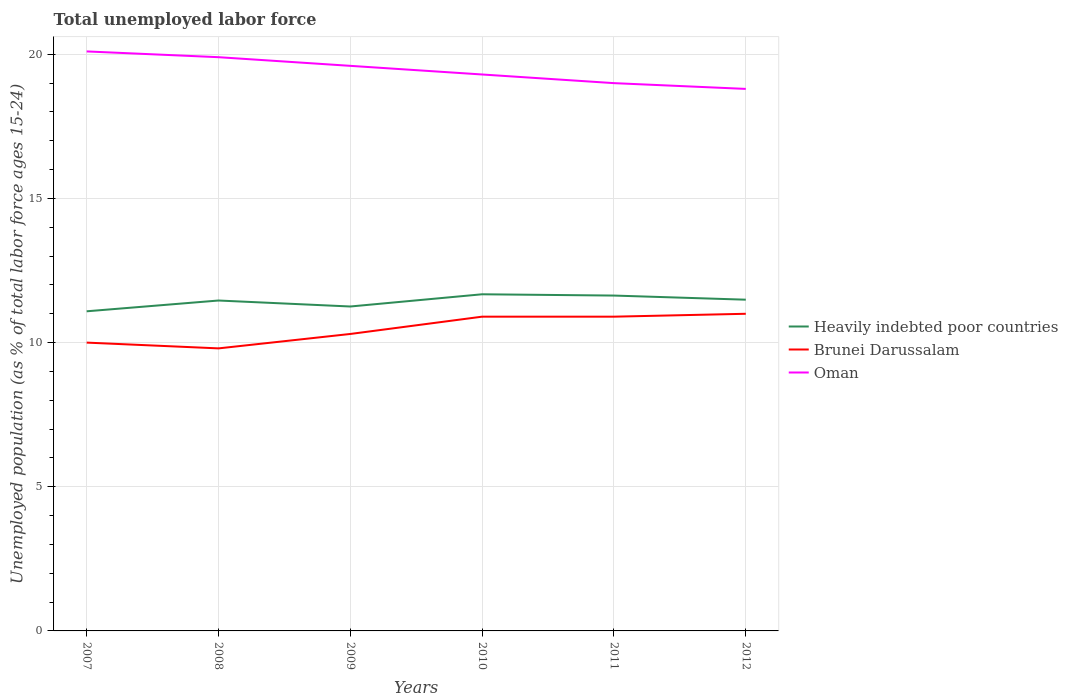Across all years, what is the maximum percentage of unemployed population in in Heavily indebted poor countries?
Give a very brief answer. 11.09. What is the total percentage of unemployed population in in Oman in the graph?
Keep it short and to the point. 1.1. What is the difference between the highest and the second highest percentage of unemployed population in in Oman?
Keep it short and to the point. 1.3. Is the percentage of unemployed population in in Brunei Darussalam strictly greater than the percentage of unemployed population in in Heavily indebted poor countries over the years?
Your response must be concise. Yes. How many lines are there?
Provide a short and direct response. 3. How many years are there in the graph?
Provide a succinct answer. 6. Does the graph contain any zero values?
Offer a very short reply. No. Where does the legend appear in the graph?
Offer a very short reply. Center right. How many legend labels are there?
Your response must be concise. 3. How are the legend labels stacked?
Make the answer very short. Vertical. What is the title of the graph?
Your answer should be compact. Total unemployed labor force. What is the label or title of the Y-axis?
Your answer should be very brief. Unemployed population (as % of total labor force ages 15-24). What is the Unemployed population (as % of total labor force ages 15-24) of Heavily indebted poor countries in 2007?
Offer a very short reply. 11.09. What is the Unemployed population (as % of total labor force ages 15-24) in Brunei Darussalam in 2007?
Ensure brevity in your answer.  10. What is the Unemployed population (as % of total labor force ages 15-24) of Oman in 2007?
Give a very brief answer. 20.1. What is the Unemployed population (as % of total labor force ages 15-24) in Heavily indebted poor countries in 2008?
Your response must be concise. 11.46. What is the Unemployed population (as % of total labor force ages 15-24) of Brunei Darussalam in 2008?
Provide a short and direct response. 9.8. What is the Unemployed population (as % of total labor force ages 15-24) in Oman in 2008?
Offer a very short reply. 19.9. What is the Unemployed population (as % of total labor force ages 15-24) in Heavily indebted poor countries in 2009?
Provide a succinct answer. 11.25. What is the Unemployed population (as % of total labor force ages 15-24) of Brunei Darussalam in 2009?
Your response must be concise. 10.3. What is the Unemployed population (as % of total labor force ages 15-24) of Oman in 2009?
Give a very brief answer. 19.6. What is the Unemployed population (as % of total labor force ages 15-24) of Heavily indebted poor countries in 2010?
Make the answer very short. 11.68. What is the Unemployed population (as % of total labor force ages 15-24) of Brunei Darussalam in 2010?
Give a very brief answer. 10.9. What is the Unemployed population (as % of total labor force ages 15-24) of Oman in 2010?
Offer a terse response. 19.3. What is the Unemployed population (as % of total labor force ages 15-24) of Heavily indebted poor countries in 2011?
Offer a terse response. 11.63. What is the Unemployed population (as % of total labor force ages 15-24) in Brunei Darussalam in 2011?
Your answer should be compact. 10.9. What is the Unemployed population (as % of total labor force ages 15-24) in Oman in 2011?
Provide a succinct answer. 19. What is the Unemployed population (as % of total labor force ages 15-24) in Heavily indebted poor countries in 2012?
Give a very brief answer. 11.49. What is the Unemployed population (as % of total labor force ages 15-24) in Brunei Darussalam in 2012?
Provide a succinct answer. 11. What is the Unemployed population (as % of total labor force ages 15-24) of Oman in 2012?
Provide a succinct answer. 18.8. Across all years, what is the maximum Unemployed population (as % of total labor force ages 15-24) of Heavily indebted poor countries?
Make the answer very short. 11.68. Across all years, what is the maximum Unemployed population (as % of total labor force ages 15-24) of Oman?
Provide a succinct answer. 20.1. Across all years, what is the minimum Unemployed population (as % of total labor force ages 15-24) of Heavily indebted poor countries?
Your answer should be very brief. 11.09. Across all years, what is the minimum Unemployed population (as % of total labor force ages 15-24) of Brunei Darussalam?
Ensure brevity in your answer.  9.8. Across all years, what is the minimum Unemployed population (as % of total labor force ages 15-24) of Oman?
Make the answer very short. 18.8. What is the total Unemployed population (as % of total labor force ages 15-24) of Heavily indebted poor countries in the graph?
Provide a short and direct response. 68.6. What is the total Unemployed population (as % of total labor force ages 15-24) in Brunei Darussalam in the graph?
Offer a terse response. 62.9. What is the total Unemployed population (as % of total labor force ages 15-24) in Oman in the graph?
Make the answer very short. 116.7. What is the difference between the Unemployed population (as % of total labor force ages 15-24) of Heavily indebted poor countries in 2007 and that in 2008?
Ensure brevity in your answer.  -0.37. What is the difference between the Unemployed population (as % of total labor force ages 15-24) of Brunei Darussalam in 2007 and that in 2008?
Your answer should be very brief. 0.2. What is the difference between the Unemployed population (as % of total labor force ages 15-24) in Heavily indebted poor countries in 2007 and that in 2009?
Provide a succinct answer. -0.17. What is the difference between the Unemployed population (as % of total labor force ages 15-24) in Brunei Darussalam in 2007 and that in 2009?
Your answer should be very brief. -0.3. What is the difference between the Unemployed population (as % of total labor force ages 15-24) in Oman in 2007 and that in 2009?
Give a very brief answer. 0.5. What is the difference between the Unemployed population (as % of total labor force ages 15-24) of Heavily indebted poor countries in 2007 and that in 2010?
Give a very brief answer. -0.59. What is the difference between the Unemployed population (as % of total labor force ages 15-24) of Heavily indebted poor countries in 2007 and that in 2011?
Keep it short and to the point. -0.55. What is the difference between the Unemployed population (as % of total labor force ages 15-24) of Oman in 2007 and that in 2011?
Offer a very short reply. 1.1. What is the difference between the Unemployed population (as % of total labor force ages 15-24) of Heavily indebted poor countries in 2007 and that in 2012?
Make the answer very short. -0.4. What is the difference between the Unemployed population (as % of total labor force ages 15-24) of Brunei Darussalam in 2007 and that in 2012?
Ensure brevity in your answer.  -1. What is the difference between the Unemployed population (as % of total labor force ages 15-24) in Oman in 2007 and that in 2012?
Your answer should be very brief. 1.3. What is the difference between the Unemployed population (as % of total labor force ages 15-24) in Heavily indebted poor countries in 2008 and that in 2009?
Your answer should be very brief. 0.21. What is the difference between the Unemployed population (as % of total labor force ages 15-24) of Brunei Darussalam in 2008 and that in 2009?
Your answer should be compact. -0.5. What is the difference between the Unemployed population (as % of total labor force ages 15-24) of Oman in 2008 and that in 2009?
Your answer should be very brief. 0.3. What is the difference between the Unemployed population (as % of total labor force ages 15-24) of Heavily indebted poor countries in 2008 and that in 2010?
Offer a terse response. -0.22. What is the difference between the Unemployed population (as % of total labor force ages 15-24) in Oman in 2008 and that in 2010?
Make the answer very short. 0.6. What is the difference between the Unemployed population (as % of total labor force ages 15-24) in Heavily indebted poor countries in 2008 and that in 2011?
Your response must be concise. -0.17. What is the difference between the Unemployed population (as % of total labor force ages 15-24) in Brunei Darussalam in 2008 and that in 2011?
Ensure brevity in your answer.  -1.1. What is the difference between the Unemployed population (as % of total labor force ages 15-24) of Heavily indebted poor countries in 2008 and that in 2012?
Your response must be concise. -0.03. What is the difference between the Unemployed population (as % of total labor force ages 15-24) in Oman in 2008 and that in 2012?
Offer a terse response. 1.1. What is the difference between the Unemployed population (as % of total labor force ages 15-24) in Heavily indebted poor countries in 2009 and that in 2010?
Provide a short and direct response. -0.42. What is the difference between the Unemployed population (as % of total labor force ages 15-24) in Brunei Darussalam in 2009 and that in 2010?
Your response must be concise. -0.6. What is the difference between the Unemployed population (as % of total labor force ages 15-24) of Oman in 2009 and that in 2010?
Offer a very short reply. 0.3. What is the difference between the Unemployed population (as % of total labor force ages 15-24) in Heavily indebted poor countries in 2009 and that in 2011?
Make the answer very short. -0.38. What is the difference between the Unemployed population (as % of total labor force ages 15-24) in Heavily indebted poor countries in 2009 and that in 2012?
Ensure brevity in your answer.  -0.24. What is the difference between the Unemployed population (as % of total labor force ages 15-24) of Brunei Darussalam in 2009 and that in 2012?
Give a very brief answer. -0.7. What is the difference between the Unemployed population (as % of total labor force ages 15-24) in Heavily indebted poor countries in 2010 and that in 2011?
Ensure brevity in your answer.  0.04. What is the difference between the Unemployed population (as % of total labor force ages 15-24) in Heavily indebted poor countries in 2010 and that in 2012?
Your response must be concise. 0.19. What is the difference between the Unemployed population (as % of total labor force ages 15-24) in Heavily indebted poor countries in 2011 and that in 2012?
Provide a short and direct response. 0.14. What is the difference between the Unemployed population (as % of total labor force ages 15-24) in Brunei Darussalam in 2011 and that in 2012?
Provide a short and direct response. -0.1. What is the difference between the Unemployed population (as % of total labor force ages 15-24) of Oman in 2011 and that in 2012?
Make the answer very short. 0.2. What is the difference between the Unemployed population (as % of total labor force ages 15-24) in Heavily indebted poor countries in 2007 and the Unemployed population (as % of total labor force ages 15-24) in Brunei Darussalam in 2008?
Your response must be concise. 1.29. What is the difference between the Unemployed population (as % of total labor force ages 15-24) in Heavily indebted poor countries in 2007 and the Unemployed population (as % of total labor force ages 15-24) in Oman in 2008?
Keep it short and to the point. -8.81. What is the difference between the Unemployed population (as % of total labor force ages 15-24) in Heavily indebted poor countries in 2007 and the Unemployed population (as % of total labor force ages 15-24) in Brunei Darussalam in 2009?
Provide a short and direct response. 0.79. What is the difference between the Unemployed population (as % of total labor force ages 15-24) of Heavily indebted poor countries in 2007 and the Unemployed population (as % of total labor force ages 15-24) of Oman in 2009?
Offer a terse response. -8.51. What is the difference between the Unemployed population (as % of total labor force ages 15-24) in Brunei Darussalam in 2007 and the Unemployed population (as % of total labor force ages 15-24) in Oman in 2009?
Keep it short and to the point. -9.6. What is the difference between the Unemployed population (as % of total labor force ages 15-24) in Heavily indebted poor countries in 2007 and the Unemployed population (as % of total labor force ages 15-24) in Brunei Darussalam in 2010?
Your response must be concise. 0.19. What is the difference between the Unemployed population (as % of total labor force ages 15-24) of Heavily indebted poor countries in 2007 and the Unemployed population (as % of total labor force ages 15-24) of Oman in 2010?
Offer a very short reply. -8.21. What is the difference between the Unemployed population (as % of total labor force ages 15-24) in Heavily indebted poor countries in 2007 and the Unemployed population (as % of total labor force ages 15-24) in Brunei Darussalam in 2011?
Your response must be concise. 0.19. What is the difference between the Unemployed population (as % of total labor force ages 15-24) of Heavily indebted poor countries in 2007 and the Unemployed population (as % of total labor force ages 15-24) of Oman in 2011?
Provide a short and direct response. -7.91. What is the difference between the Unemployed population (as % of total labor force ages 15-24) in Heavily indebted poor countries in 2007 and the Unemployed population (as % of total labor force ages 15-24) in Brunei Darussalam in 2012?
Give a very brief answer. 0.09. What is the difference between the Unemployed population (as % of total labor force ages 15-24) in Heavily indebted poor countries in 2007 and the Unemployed population (as % of total labor force ages 15-24) in Oman in 2012?
Give a very brief answer. -7.71. What is the difference between the Unemployed population (as % of total labor force ages 15-24) of Brunei Darussalam in 2007 and the Unemployed population (as % of total labor force ages 15-24) of Oman in 2012?
Keep it short and to the point. -8.8. What is the difference between the Unemployed population (as % of total labor force ages 15-24) in Heavily indebted poor countries in 2008 and the Unemployed population (as % of total labor force ages 15-24) in Brunei Darussalam in 2009?
Your answer should be very brief. 1.16. What is the difference between the Unemployed population (as % of total labor force ages 15-24) in Heavily indebted poor countries in 2008 and the Unemployed population (as % of total labor force ages 15-24) in Oman in 2009?
Keep it short and to the point. -8.14. What is the difference between the Unemployed population (as % of total labor force ages 15-24) in Brunei Darussalam in 2008 and the Unemployed population (as % of total labor force ages 15-24) in Oman in 2009?
Your response must be concise. -9.8. What is the difference between the Unemployed population (as % of total labor force ages 15-24) of Heavily indebted poor countries in 2008 and the Unemployed population (as % of total labor force ages 15-24) of Brunei Darussalam in 2010?
Ensure brevity in your answer.  0.56. What is the difference between the Unemployed population (as % of total labor force ages 15-24) of Heavily indebted poor countries in 2008 and the Unemployed population (as % of total labor force ages 15-24) of Oman in 2010?
Your response must be concise. -7.84. What is the difference between the Unemployed population (as % of total labor force ages 15-24) of Brunei Darussalam in 2008 and the Unemployed population (as % of total labor force ages 15-24) of Oman in 2010?
Provide a short and direct response. -9.5. What is the difference between the Unemployed population (as % of total labor force ages 15-24) of Heavily indebted poor countries in 2008 and the Unemployed population (as % of total labor force ages 15-24) of Brunei Darussalam in 2011?
Give a very brief answer. 0.56. What is the difference between the Unemployed population (as % of total labor force ages 15-24) of Heavily indebted poor countries in 2008 and the Unemployed population (as % of total labor force ages 15-24) of Oman in 2011?
Your answer should be compact. -7.54. What is the difference between the Unemployed population (as % of total labor force ages 15-24) of Brunei Darussalam in 2008 and the Unemployed population (as % of total labor force ages 15-24) of Oman in 2011?
Give a very brief answer. -9.2. What is the difference between the Unemployed population (as % of total labor force ages 15-24) in Heavily indebted poor countries in 2008 and the Unemployed population (as % of total labor force ages 15-24) in Brunei Darussalam in 2012?
Give a very brief answer. 0.46. What is the difference between the Unemployed population (as % of total labor force ages 15-24) in Heavily indebted poor countries in 2008 and the Unemployed population (as % of total labor force ages 15-24) in Oman in 2012?
Give a very brief answer. -7.34. What is the difference between the Unemployed population (as % of total labor force ages 15-24) of Brunei Darussalam in 2008 and the Unemployed population (as % of total labor force ages 15-24) of Oman in 2012?
Your answer should be compact. -9. What is the difference between the Unemployed population (as % of total labor force ages 15-24) of Heavily indebted poor countries in 2009 and the Unemployed population (as % of total labor force ages 15-24) of Brunei Darussalam in 2010?
Your response must be concise. 0.35. What is the difference between the Unemployed population (as % of total labor force ages 15-24) of Heavily indebted poor countries in 2009 and the Unemployed population (as % of total labor force ages 15-24) of Oman in 2010?
Your response must be concise. -8.05. What is the difference between the Unemployed population (as % of total labor force ages 15-24) of Brunei Darussalam in 2009 and the Unemployed population (as % of total labor force ages 15-24) of Oman in 2010?
Your answer should be compact. -9. What is the difference between the Unemployed population (as % of total labor force ages 15-24) in Heavily indebted poor countries in 2009 and the Unemployed population (as % of total labor force ages 15-24) in Brunei Darussalam in 2011?
Offer a very short reply. 0.35. What is the difference between the Unemployed population (as % of total labor force ages 15-24) of Heavily indebted poor countries in 2009 and the Unemployed population (as % of total labor force ages 15-24) of Oman in 2011?
Provide a succinct answer. -7.75. What is the difference between the Unemployed population (as % of total labor force ages 15-24) in Brunei Darussalam in 2009 and the Unemployed population (as % of total labor force ages 15-24) in Oman in 2011?
Your response must be concise. -8.7. What is the difference between the Unemployed population (as % of total labor force ages 15-24) of Heavily indebted poor countries in 2009 and the Unemployed population (as % of total labor force ages 15-24) of Brunei Darussalam in 2012?
Provide a succinct answer. 0.25. What is the difference between the Unemployed population (as % of total labor force ages 15-24) in Heavily indebted poor countries in 2009 and the Unemployed population (as % of total labor force ages 15-24) in Oman in 2012?
Your response must be concise. -7.55. What is the difference between the Unemployed population (as % of total labor force ages 15-24) of Brunei Darussalam in 2009 and the Unemployed population (as % of total labor force ages 15-24) of Oman in 2012?
Make the answer very short. -8.5. What is the difference between the Unemployed population (as % of total labor force ages 15-24) in Heavily indebted poor countries in 2010 and the Unemployed population (as % of total labor force ages 15-24) in Brunei Darussalam in 2011?
Provide a short and direct response. 0.78. What is the difference between the Unemployed population (as % of total labor force ages 15-24) in Heavily indebted poor countries in 2010 and the Unemployed population (as % of total labor force ages 15-24) in Oman in 2011?
Offer a very short reply. -7.32. What is the difference between the Unemployed population (as % of total labor force ages 15-24) in Heavily indebted poor countries in 2010 and the Unemployed population (as % of total labor force ages 15-24) in Brunei Darussalam in 2012?
Provide a succinct answer. 0.68. What is the difference between the Unemployed population (as % of total labor force ages 15-24) in Heavily indebted poor countries in 2010 and the Unemployed population (as % of total labor force ages 15-24) in Oman in 2012?
Ensure brevity in your answer.  -7.12. What is the difference between the Unemployed population (as % of total labor force ages 15-24) of Heavily indebted poor countries in 2011 and the Unemployed population (as % of total labor force ages 15-24) of Brunei Darussalam in 2012?
Your answer should be compact. 0.63. What is the difference between the Unemployed population (as % of total labor force ages 15-24) in Heavily indebted poor countries in 2011 and the Unemployed population (as % of total labor force ages 15-24) in Oman in 2012?
Your response must be concise. -7.17. What is the average Unemployed population (as % of total labor force ages 15-24) in Heavily indebted poor countries per year?
Offer a terse response. 11.43. What is the average Unemployed population (as % of total labor force ages 15-24) of Brunei Darussalam per year?
Your answer should be very brief. 10.48. What is the average Unemployed population (as % of total labor force ages 15-24) of Oman per year?
Provide a succinct answer. 19.45. In the year 2007, what is the difference between the Unemployed population (as % of total labor force ages 15-24) in Heavily indebted poor countries and Unemployed population (as % of total labor force ages 15-24) in Brunei Darussalam?
Give a very brief answer. 1.09. In the year 2007, what is the difference between the Unemployed population (as % of total labor force ages 15-24) in Heavily indebted poor countries and Unemployed population (as % of total labor force ages 15-24) in Oman?
Give a very brief answer. -9.01. In the year 2007, what is the difference between the Unemployed population (as % of total labor force ages 15-24) in Brunei Darussalam and Unemployed population (as % of total labor force ages 15-24) in Oman?
Ensure brevity in your answer.  -10.1. In the year 2008, what is the difference between the Unemployed population (as % of total labor force ages 15-24) in Heavily indebted poor countries and Unemployed population (as % of total labor force ages 15-24) in Brunei Darussalam?
Your answer should be compact. 1.66. In the year 2008, what is the difference between the Unemployed population (as % of total labor force ages 15-24) of Heavily indebted poor countries and Unemployed population (as % of total labor force ages 15-24) of Oman?
Give a very brief answer. -8.44. In the year 2009, what is the difference between the Unemployed population (as % of total labor force ages 15-24) of Heavily indebted poor countries and Unemployed population (as % of total labor force ages 15-24) of Brunei Darussalam?
Offer a terse response. 0.95. In the year 2009, what is the difference between the Unemployed population (as % of total labor force ages 15-24) of Heavily indebted poor countries and Unemployed population (as % of total labor force ages 15-24) of Oman?
Offer a terse response. -8.35. In the year 2009, what is the difference between the Unemployed population (as % of total labor force ages 15-24) of Brunei Darussalam and Unemployed population (as % of total labor force ages 15-24) of Oman?
Your response must be concise. -9.3. In the year 2010, what is the difference between the Unemployed population (as % of total labor force ages 15-24) in Heavily indebted poor countries and Unemployed population (as % of total labor force ages 15-24) in Brunei Darussalam?
Your response must be concise. 0.78. In the year 2010, what is the difference between the Unemployed population (as % of total labor force ages 15-24) of Heavily indebted poor countries and Unemployed population (as % of total labor force ages 15-24) of Oman?
Offer a very short reply. -7.62. In the year 2010, what is the difference between the Unemployed population (as % of total labor force ages 15-24) in Brunei Darussalam and Unemployed population (as % of total labor force ages 15-24) in Oman?
Your response must be concise. -8.4. In the year 2011, what is the difference between the Unemployed population (as % of total labor force ages 15-24) in Heavily indebted poor countries and Unemployed population (as % of total labor force ages 15-24) in Brunei Darussalam?
Give a very brief answer. 0.73. In the year 2011, what is the difference between the Unemployed population (as % of total labor force ages 15-24) in Heavily indebted poor countries and Unemployed population (as % of total labor force ages 15-24) in Oman?
Offer a terse response. -7.37. In the year 2012, what is the difference between the Unemployed population (as % of total labor force ages 15-24) of Heavily indebted poor countries and Unemployed population (as % of total labor force ages 15-24) of Brunei Darussalam?
Provide a succinct answer. 0.49. In the year 2012, what is the difference between the Unemployed population (as % of total labor force ages 15-24) in Heavily indebted poor countries and Unemployed population (as % of total labor force ages 15-24) in Oman?
Offer a terse response. -7.31. What is the ratio of the Unemployed population (as % of total labor force ages 15-24) of Heavily indebted poor countries in 2007 to that in 2008?
Offer a very short reply. 0.97. What is the ratio of the Unemployed population (as % of total labor force ages 15-24) of Brunei Darussalam in 2007 to that in 2008?
Make the answer very short. 1.02. What is the ratio of the Unemployed population (as % of total labor force ages 15-24) of Oman in 2007 to that in 2008?
Your response must be concise. 1.01. What is the ratio of the Unemployed population (as % of total labor force ages 15-24) in Heavily indebted poor countries in 2007 to that in 2009?
Offer a very short reply. 0.99. What is the ratio of the Unemployed population (as % of total labor force ages 15-24) in Brunei Darussalam in 2007 to that in 2009?
Offer a terse response. 0.97. What is the ratio of the Unemployed population (as % of total labor force ages 15-24) in Oman in 2007 to that in 2009?
Offer a very short reply. 1.03. What is the ratio of the Unemployed population (as % of total labor force ages 15-24) of Heavily indebted poor countries in 2007 to that in 2010?
Your response must be concise. 0.95. What is the ratio of the Unemployed population (as % of total labor force ages 15-24) of Brunei Darussalam in 2007 to that in 2010?
Provide a short and direct response. 0.92. What is the ratio of the Unemployed population (as % of total labor force ages 15-24) in Oman in 2007 to that in 2010?
Provide a short and direct response. 1.04. What is the ratio of the Unemployed population (as % of total labor force ages 15-24) of Heavily indebted poor countries in 2007 to that in 2011?
Provide a short and direct response. 0.95. What is the ratio of the Unemployed population (as % of total labor force ages 15-24) of Brunei Darussalam in 2007 to that in 2011?
Make the answer very short. 0.92. What is the ratio of the Unemployed population (as % of total labor force ages 15-24) of Oman in 2007 to that in 2011?
Provide a short and direct response. 1.06. What is the ratio of the Unemployed population (as % of total labor force ages 15-24) of Heavily indebted poor countries in 2007 to that in 2012?
Give a very brief answer. 0.96. What is the ratio of the Unemployed population (as % of total labor force ages 15-24) of Brunei Darussalam in 2007 to that in 2012?
Offer a very short reply. 0.91. What is the ratio of the Unemployed population (as % of total labor force ages 15-24) in Oman in 2007 to that in 2012?
Provide a succinct answer. 1.07. What is the ratio of the Unemployed population (as % of total labor force ages 15-24) in Heavily indebted poor countries in 2008 to that in 2009?
Ensure brevity in your answer.  1.02. What is the ratio of the Unemployed population (as % of total labor force ages 15-24) of Brunei Darussalam in 2008 to that in 2009?
Offer a terse response. 0.95. What is the ratio of the Unemployed population (as % of total labor force ages 15-24) of Oman in 2008 to that in 2009?
Make the answer very short. 1.02. What is the ratio of the Unemployed population (as % of total labor force ages 15-24) in Heavily indebted poor countries in 2008 to that in 2010?
Make the answer very short. 0.98. What is the ratio of the Unemployed population (as % of total labor force ages 15-24) of Brunei Darussalam in 2008 to that in 2010?
Offer a very short reply. 0.9. What is the ratio of the Unemployed population (as % of total labor force ages 15-24) of Oman in 2008 to that in 2010?
Ensure brevity in your answer.  1.03. What is the ratio of the Unemployed population (as % of total labor force ages 15-24) in Heavily indebted poor countries in 2008 to that in 2011?
Give a very brief answer. 0.99. What is the ratio of the Unemployed population (as % of total labor force ages 15-24) of Brunei Darussalam in 2008 to that in 2011?
Your answer should be very brief. 0.9. What is the ratio of the Unemployed population (as % of total labor force ages 15-24) in Oman in 2008 to that in 2011?
Provide a short and direct response. 1.05. What is the ratio of the Unemployed population (as % of total labor force ages 15-24) of Brunei Darussalam in 2008 to that in 2012?
Provide a succinct answer. 0.89. What is the ratio of the Unemployed population (as % of total labor force ages 15-24) in Oman in 2008 to that in 2012?
Your answer should be compact. 1.06. What is the ratio of the Unemployed population (as % of total labor force ages 15-24) of Heavily indebted poor countries in 2009 to that in 2010?
Ensure brevity in your answer.  0.96. What is the ratio of the Unemployed population (as % of total labor force ages 15-24) of Brunei Darussalam in 2009 to that in 2010?
Provide a short and direct response. 0.94. What is the ratio of the Unemployed population (as % of total labor force ages 15-24) in Oman in 2009 to that in 2010?
Ensure brevity in your answer.  1.02. What is the ratio of the Unemployed population (as % of total labor force ages 15-24) in Heavily indebted poor countries in 2009 to that in 2011?
Your response must be concise. 0.97. What is the ratio of the Unemployed population (as % of total labor force ages 15-24) in Brunei Darussalam in 2009 to that in 2011?
Ensure brevity in your answer.  0.94. What is the ratio of the Unemployed population (as % of total labor force ages 15-24) in Oman in 2009 to that in 2011?
Keep it short and to the point. 1.03. What is the ratio of the Unemployed population (as % of total labor force ages 15-24) in Heavily indebted poor countries in 2009 to that in 2012?
Keep it short and to the point. 0.98. What is the ratio of the Unemployed population (as % of total labor force ages 15-24) of Brunei Darussalam in 2009 to that in 2012?
Give a very brief answer. 0.94. What is the ratio of the Unemployed population (as % of total labor force ages 15-24) of Oman in 2009 to that in 2012?
Provide a succinct answer. 1.04. What is the ratio of the Unemployed population (as % of total labor force ages 15-24) in Heavily indebted poor countries in 2010 to that in 2011?
Give a very brief answer. 1. What is the ratio of the Unemployed population (as % of total labor force ages 15-24) in Oman in 2010 to that in 2011?
Your answer should be compact. 1.02. What is the ratio of the Unemployed population (as % of total labor force ages 15-24) in Heavily indebted poor countries in 2010 to that in 2012?
Ensure brevity in your answer.  1.02. What is the ratio of the Unemployed population (as % of total labor force ages 15-24) in Brunei Darussalam in 2010 to that in 2012?
Your response must be concise. 0.99. What is the ratio of the Unemployed population (as % of total labor force ages 15-24) in Oman in 2010 to that in 2012?
Keep it short and to the point. 1.03. What is the ratio of the Unemployed population (as % of total labor force ages 15-24) in Heavily indebted poor countries in 2011 to that in 2012?
Provide a short and direct response. 1.01. What is the ratio of the Unemployed population (as % of total labor force ages 15-24) of Brunei Darussalam in 2011 to that in 2012?
Ensure brevity in your answer.  0.99. What is the ratio of the Unemployed population (as % of total labor force ages 15-24) in Oman in 2011 to that in 2012?
Provide a succinct answer. 1.01. What is the difference between the highest and the second highest Unemployed population (as % of total labor force ages 15-24) in Heavily indebted poor countries?
Offer a terse response. 0.04. What is the difference between the highest and the second highest Unemployed population (as % of total labor force ages 15-24) in Oman?
Provide a short and direct response. 0.2. What is the difference between the highest and the lowest Unemployed population (as % of total labor force ages 15-24) of Heavily indebted poor countries?
Your answer should be very brief. 0.59. 